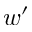Convert formula to latex. <formula><loc_0><loc_0><loc_500><loc_500>w ^ { \prime }</formula> 